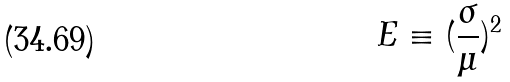<formula> <loc_0><loc_0><loc_500><loc_500>E \equiv ( \frac { \sigma } { \mu } ) ^ { 2 }</formula> 